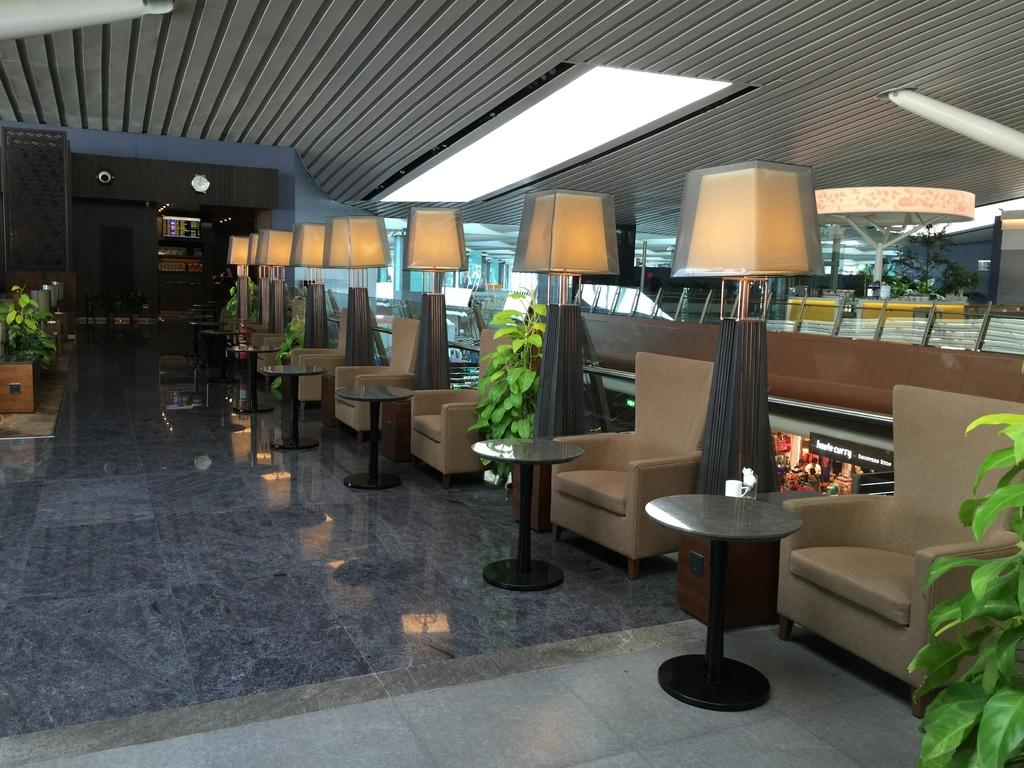What type of furniture is present in the image? There are chairs and tables in the image. What else can be seen in the image besides furniture? There are plants and lights visible in the image. What is visible in the background of the image? There are shops visible in the background of the image. What is at the bottom of the image? There is a floor at the bottom of the image. What type of pollution can be seen in the image? There is no visible pollution in the image. How many balls are present in the image? There are no balls present in the image. 